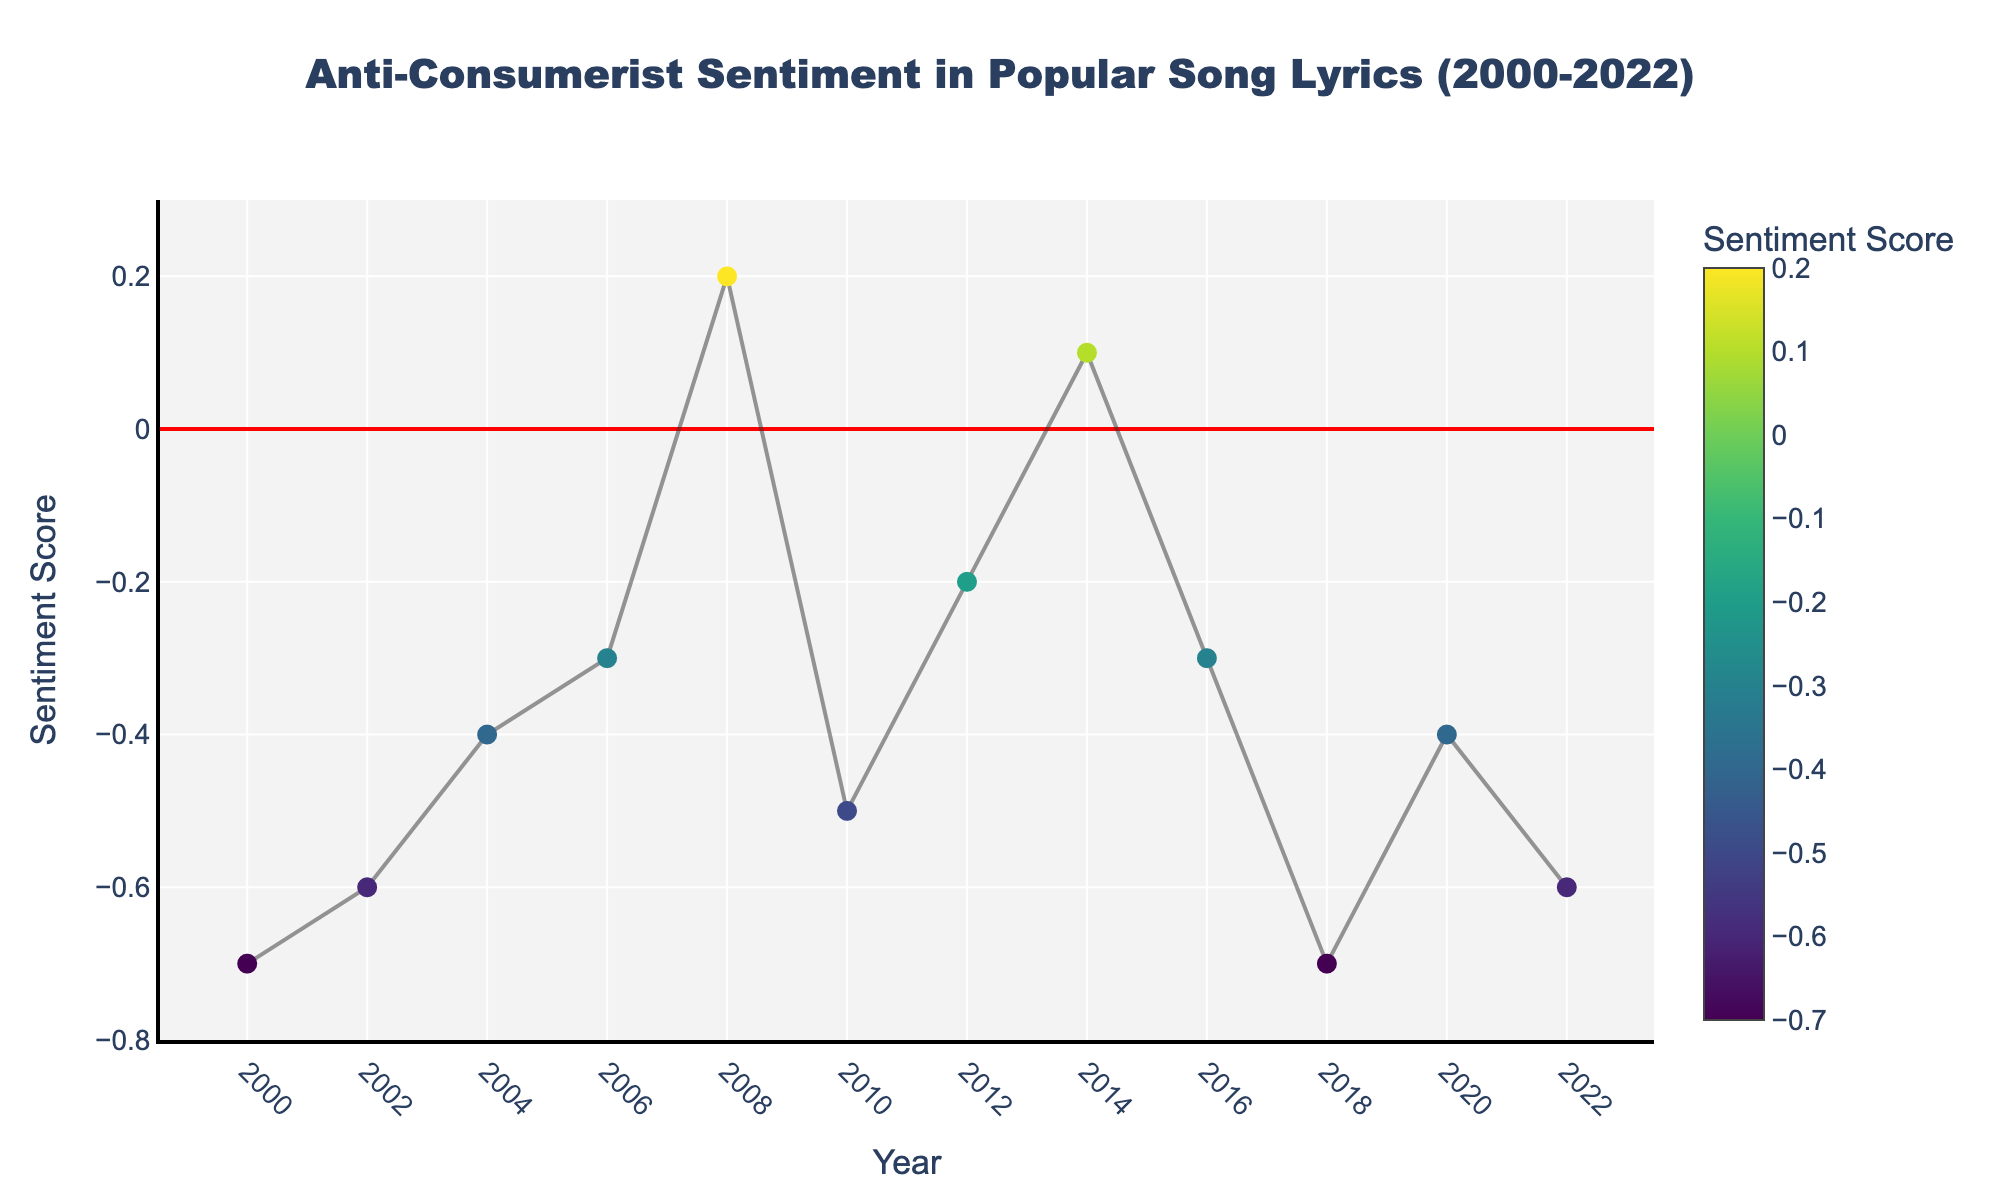How many artists are featured in the plot? Count the unique artists mentioned by their names in the hovertext of the plotted data points.
Answer: 11 What year has the most negative sentiment score? Look for the lowest point (most negative) on the plot and check its corresponding year on the x-axis.
Answer: 2018 Which song has the highest sentiment score? Identify the highest point on the plot and note the song's name from its hovertext.
Answer: Viva La Vida How has the sentiment toward consumerism in lyrics changed from 2000 to 2022? Observe the trend line from 2000 to 2022: if it generally ascends, the sentiment is becoming less negative; if it descends, the sentiment is becoming more negative.
Answer: Generally stable with fluctuations What is the average sentiment score for songs released in even-numbered years? Extract and average the sentiment scores of songs from even-numbered years (2000, 2002, etc.): (-0.7 + -0.6 + -0.3 + 0.2 + -0.2 + 0.1 + -0.6)/7
Answer: -0.3 Compare the sentiment scores between Radiohead's "Idioteque" and Childish Gambino's "This Is America." Which one is more negative? Look at the sentiment scores of the two songs and compare their values.
Answer: This Is America What general trend does the red line at y=0 indicate? This red line (zero line) on the y-axis separates positive and negative sentiment scores; it provides a visual reference for neutrality.
Answer: Neutral sentiment How many songs have a positive sentiment score? Count the number of points that lie above the red line (y=0).
Answer: 2 What is the sentiment score for "Walking in the Snow" by Run The Jewels? Identify the data point associated with "Walking in the Snow" and read its sentiment score from the y-axis.
Answer: -0.6 Has there been any year with a positive sentiment score trend in the early 2000s? Examine the plot for any data points above the red line in the early 2000s (2000-2004).
Answer: No 